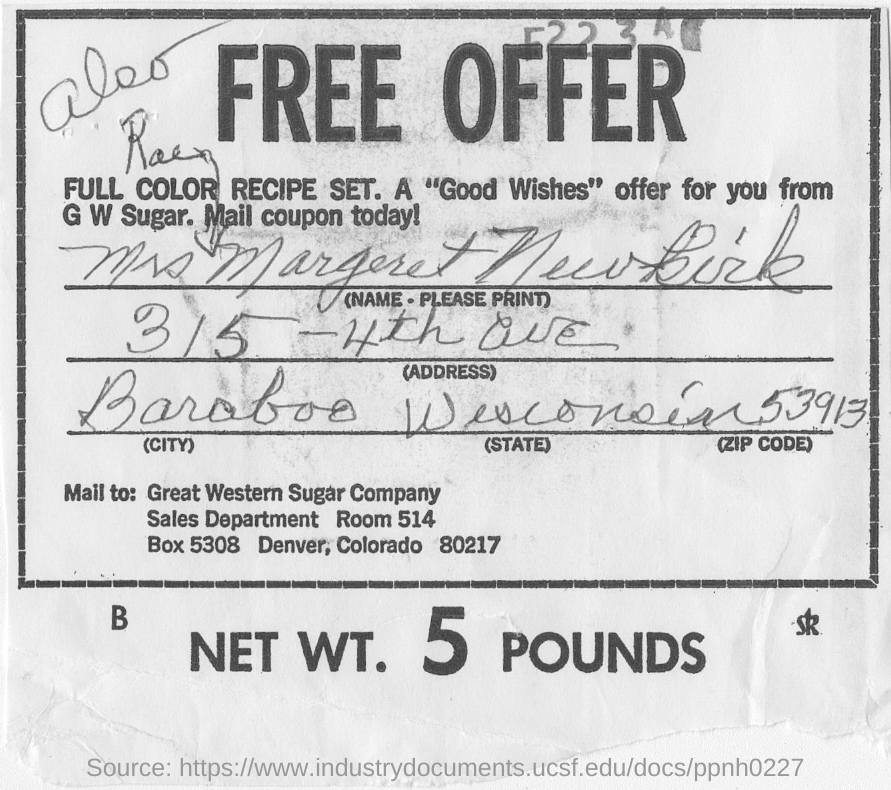What can you tell about the era in which this coupon was likely used? Judging by the font styles, the handwritten script, and the overall look of the coupon, it appears to be from several decades ago, possibly from the mid-20th century. The use of a mail-in coupon reflects marketing practices that were more common in that period before the widespread adoption of digital communications and promotions. 